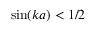Convert formula to latex. <formula><loc_0><loc_0><loc_500><loc_500>\sin ( k a ) < 1 / 2</formula> 